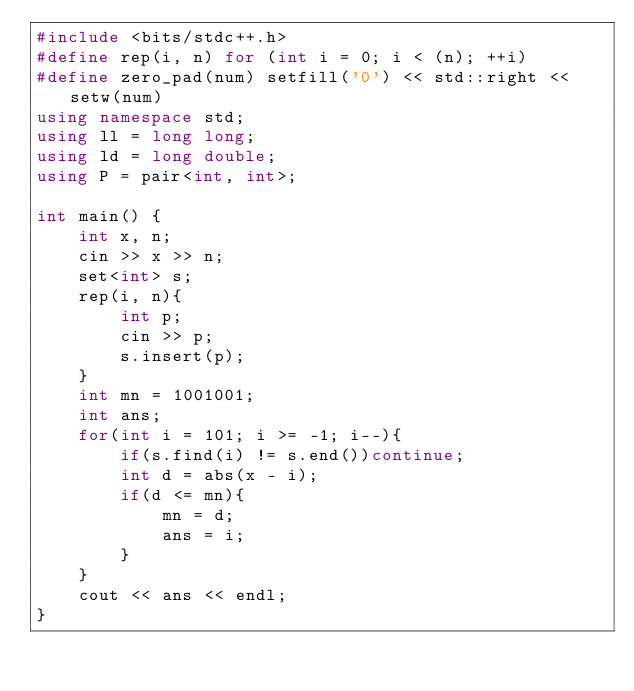Convert code to text. <code><loc_0><loc_0><loc_500><loc_500><_C++_>#include <bits/stdc++.h>
#define rep(i, n) for (int i = 0; i < (n); ++i)
#define zero_pad(num) setfill('0') << std::right << setw(num)
using namespace std;
using ll = long long;
using ld = long double;
using P = pair<int, int>;

int main() {
    int x, n;
    cin >> x >> n;
    set<int> s;
    rep(i, n){
        int p;
        cin >> p;
        s.insert(p);
    }
    int mn = 1001001;
    int ans;
    for(int i = 101; i >= -1; i--){
        if(s.find(i) != s.end())continue;
        int d = abs(x - i);
        if(d <= mn){
            mn = d;
            ans = i;
        }
    }
    cout << ans << endl;
}</code> 